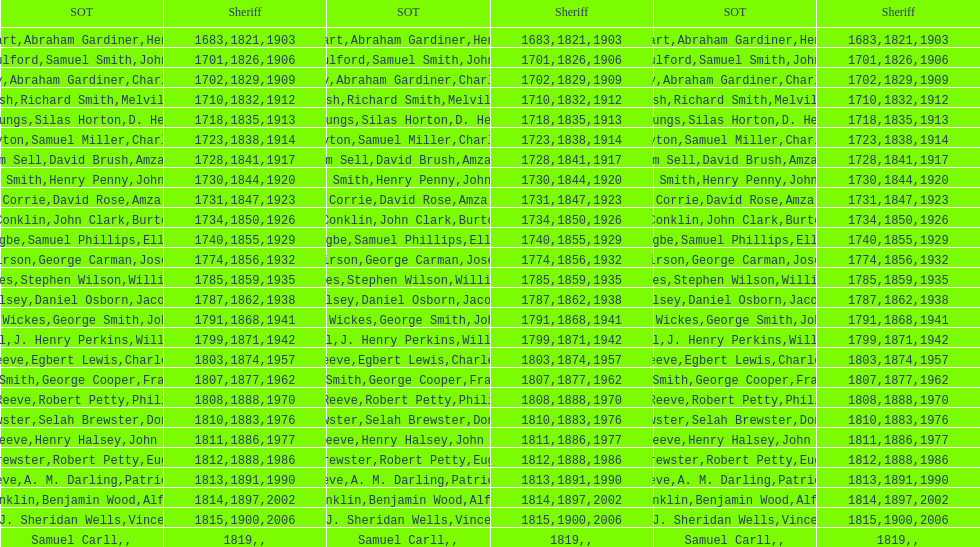Which sheriff came before thomas wickes? James Muirson. 